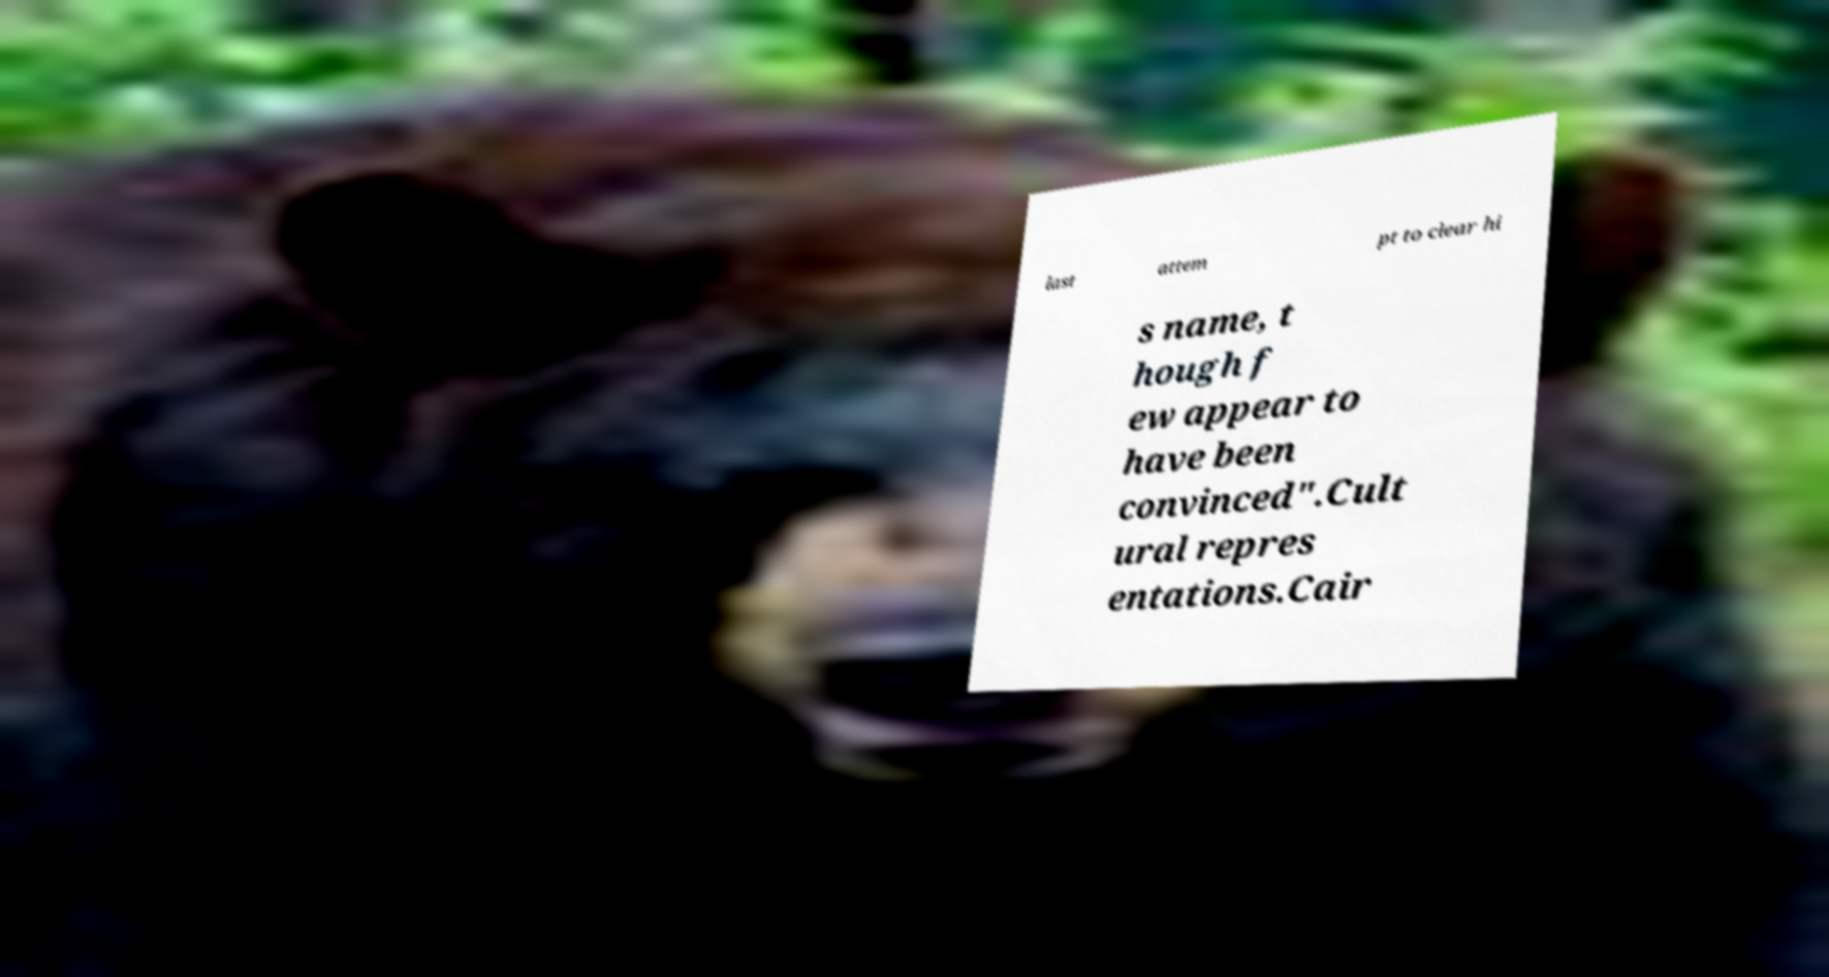Could you extract and type out the text from this image? last attem pt to clear hi s name, t hough f ew appear to have been convinced".Cult ural repres entations.Cair 